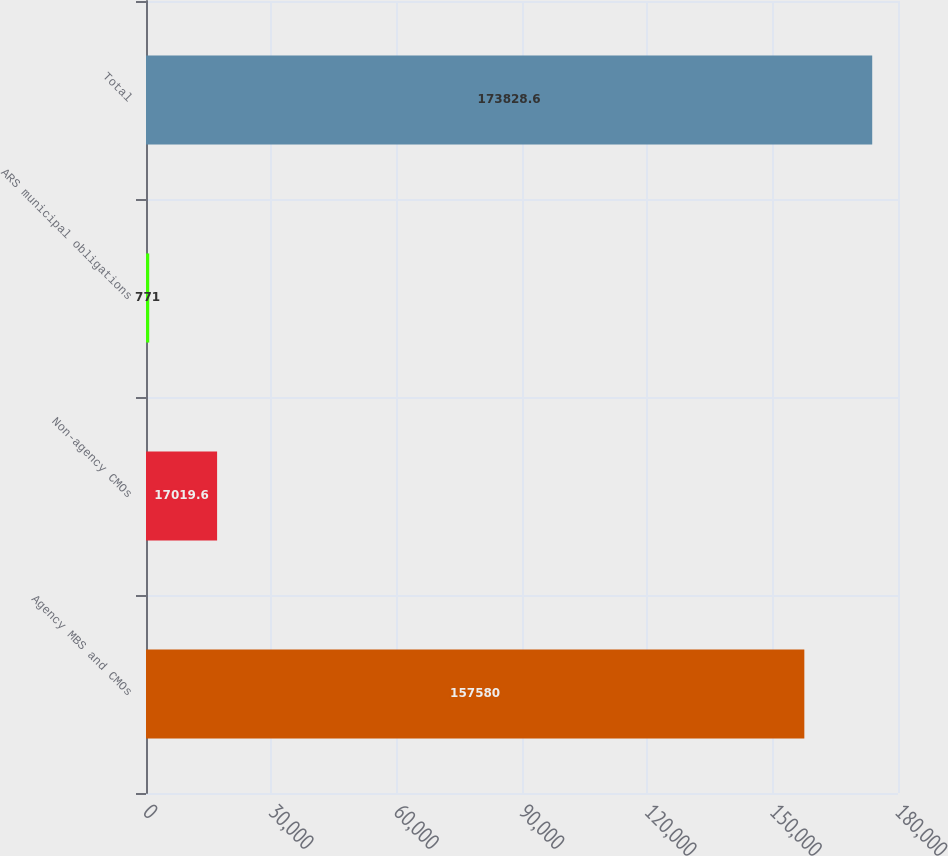Convert chart. <chart><loc_0><loc_0><loc_500><loc_500><bar_chart><fcel>Agency MBS and CMOs<fcel>Non-agency CMOs<fcel>ARS municipal obligations<fcel>Total<nl><fcel>157580<fcel>17019.6<fcel>771<fcel>173829<nl></chart> 